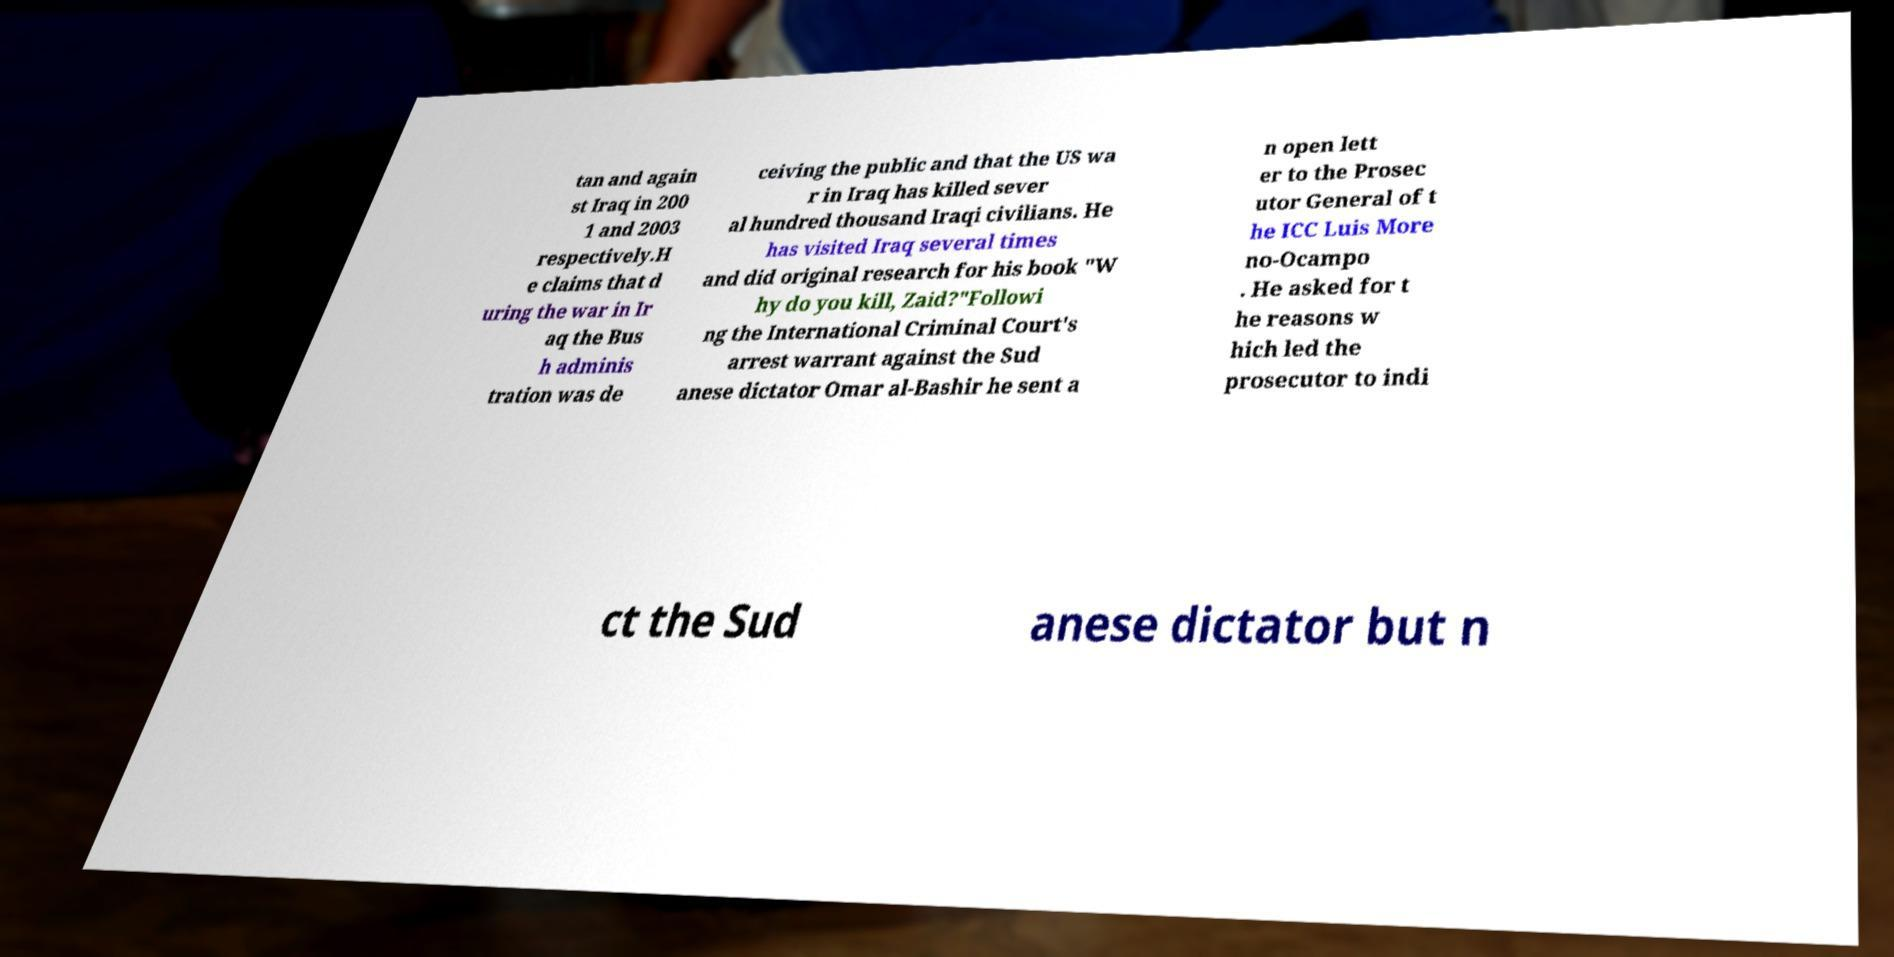Please read and relay the text visible in this image. What does it say? tan and again st Iraq in 200 1 and 2003 respectively.H e claims that d uring the war in Ir aq the Bus h adminis tration was de ceiving the public and that the US wa r in Iraq has killed sever al hundred thousand Iraqi civilians. He has visited Iraq several times and did original research for his book "W hy do you kill, Zaid?"Followi ng the International Criminal Court's arrest warrant against the Sud anese dictator Omar al-Bashir he sent a n open lett er to the Prosec utor General of t he ICC Luis More no-Ocampo . He asked for t he reasons w hich led the prosecutor to indi ct the Sud anese dictator but n 